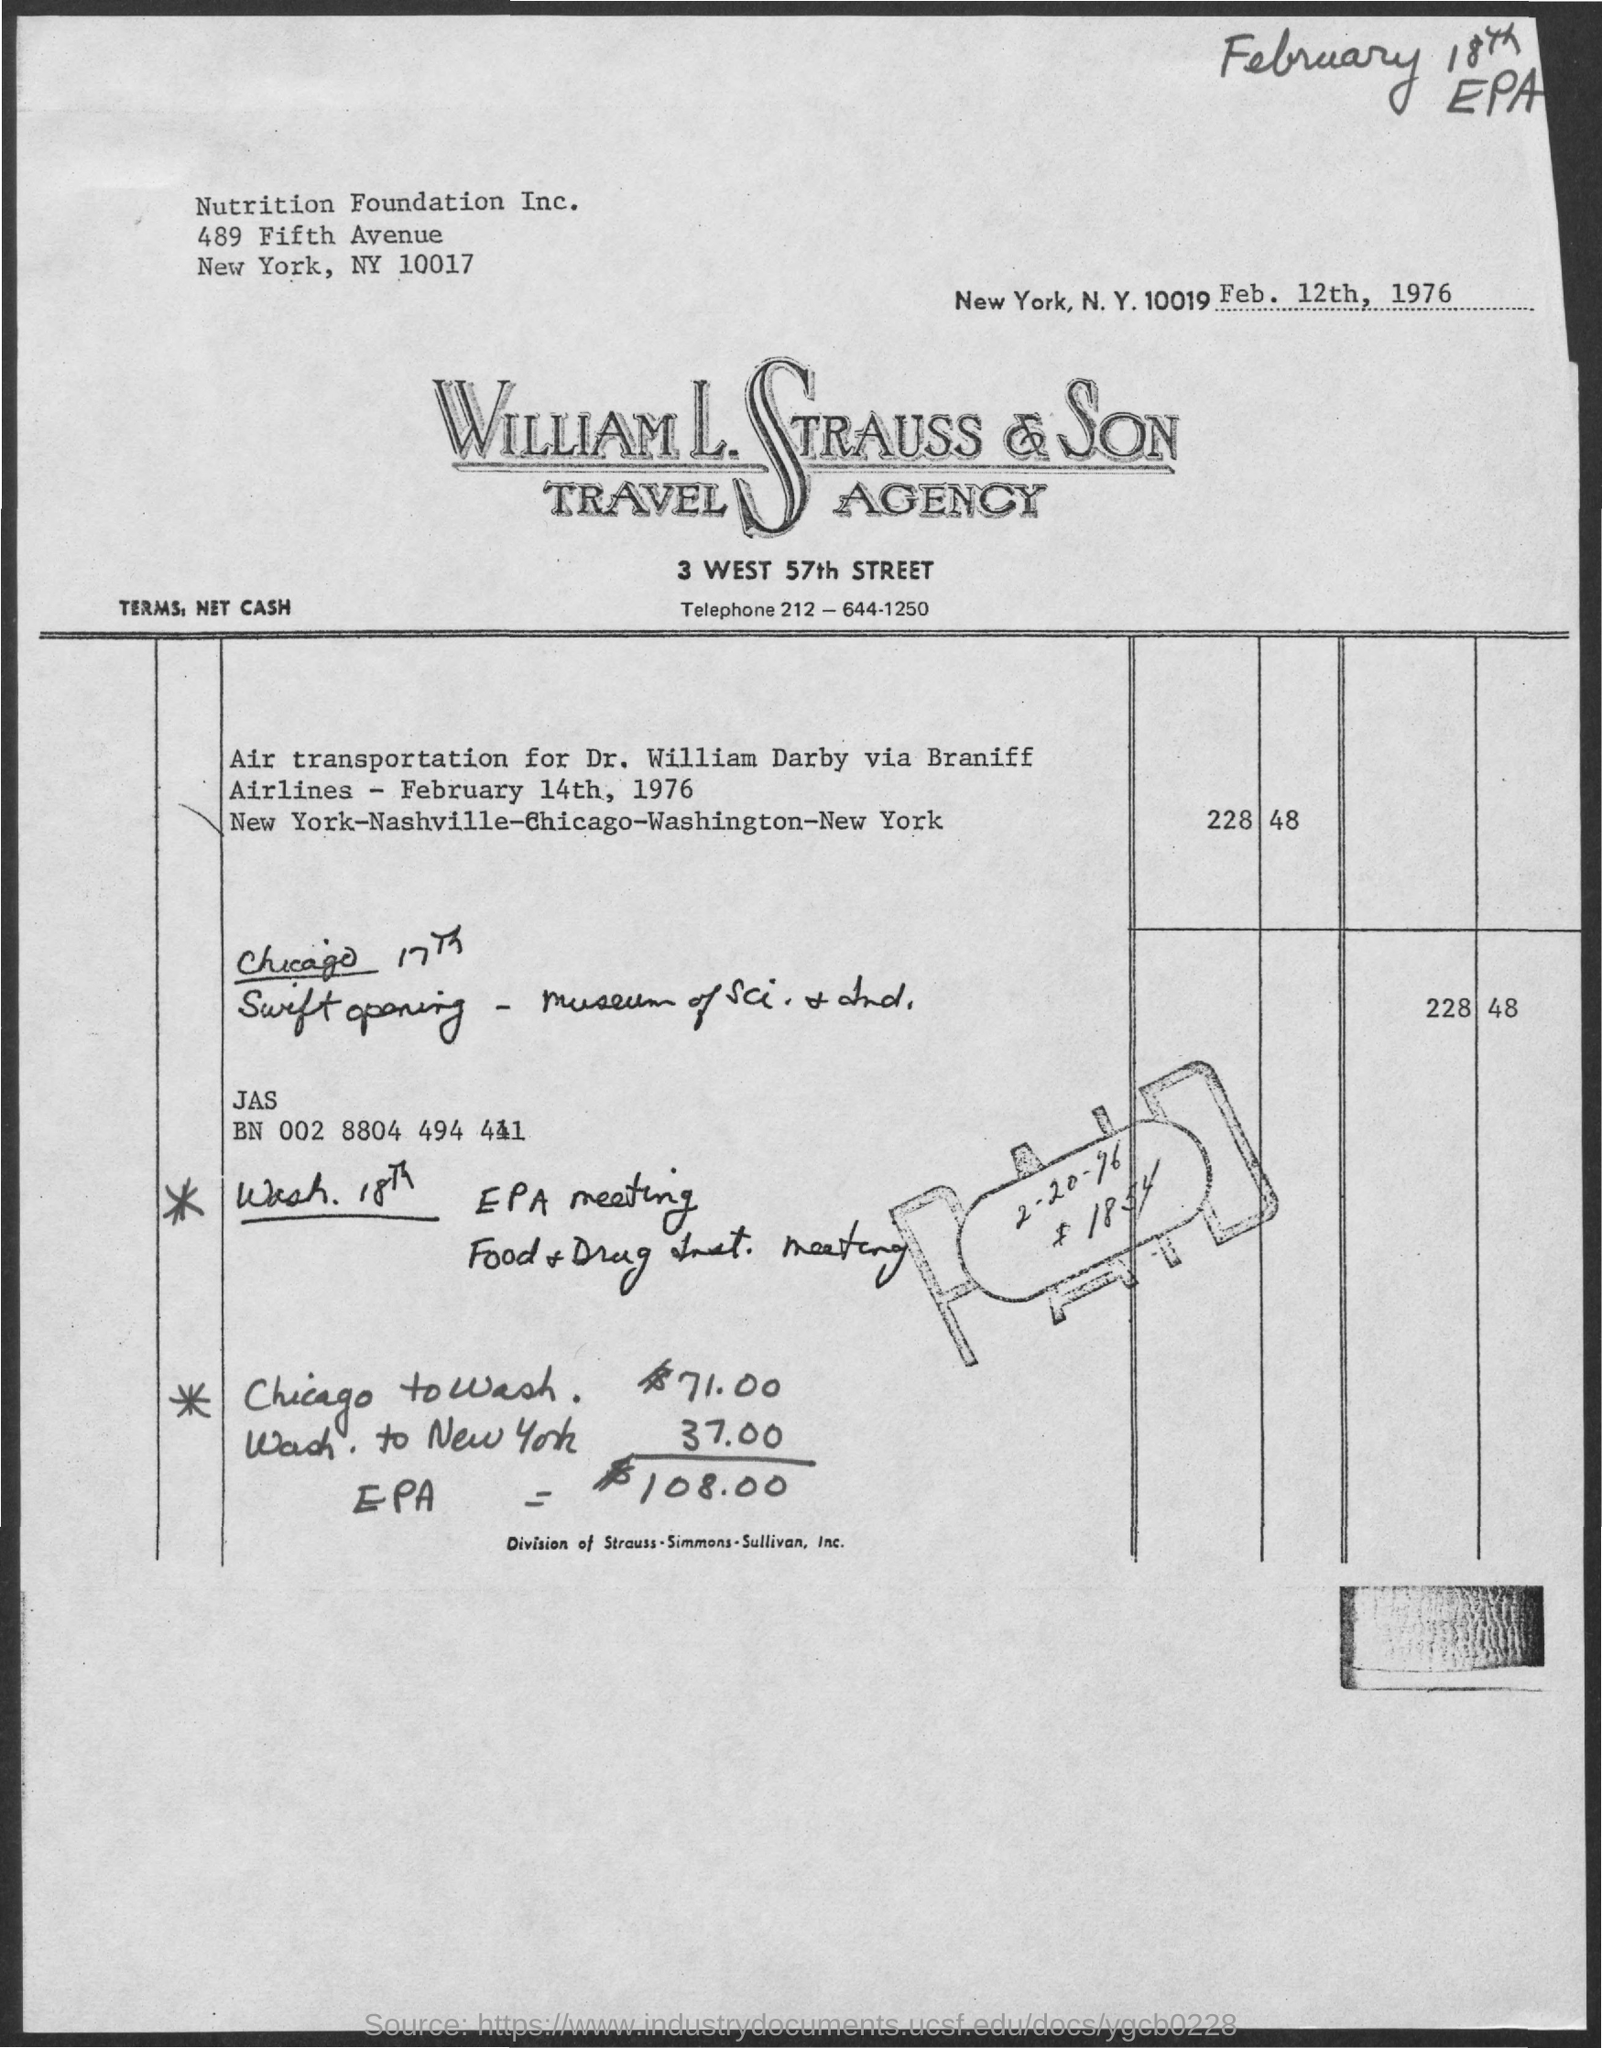What is the paid date mentioned ?
Provide a short and direct response. 2-20-96. 